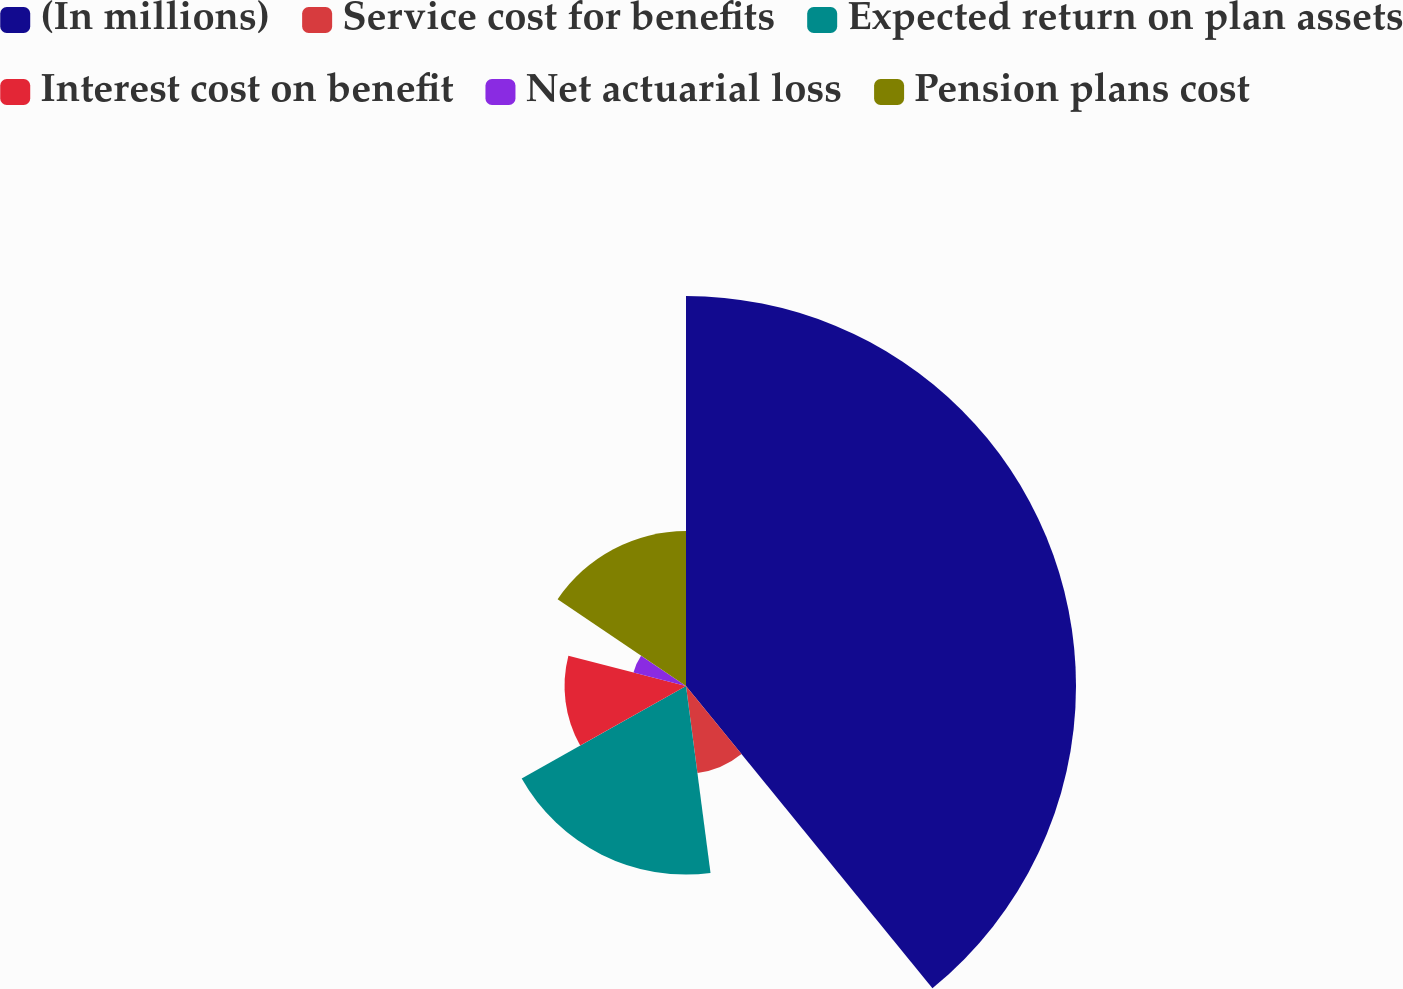<chart> <loc_0><loc_0><loc_500><loc_500><pie_chart><fcel>(In millions)<fcel>Service cost for benefits<fcel>Expected return on plan assets<fcel>Interest cost on benefit<fcel>Net actuarial loss<fcel>Pension plans cost<nl><fcel>39.11%<fcel>8.81%<fcel>18.91%<fcel>12.18%<fcel>5.44%<fcel>15.54%<nl></chart> 